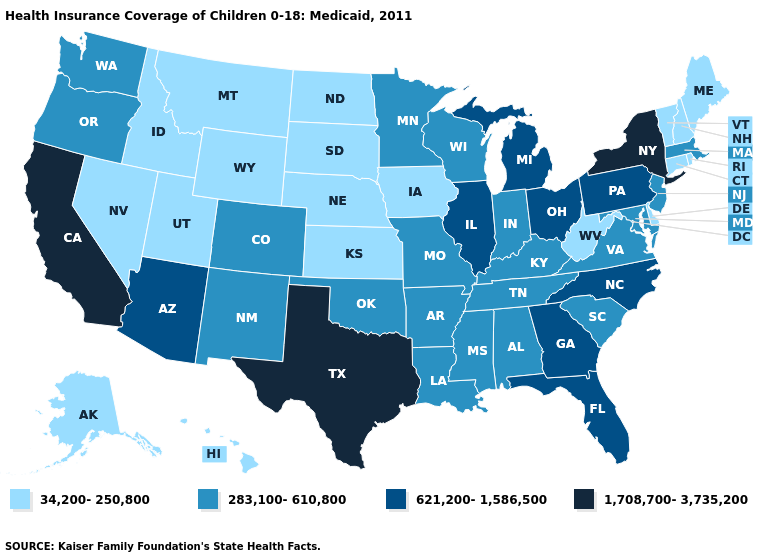Name the states that have a value in the range 621,200-1,586,500?
Quick response, please. Arizona, Florida, Georgia, Illinois, Michigan, North Carolina, Ohio, Pennsylvania. Among the states that border New Hampshire , does Maine have the lowest value?
Write a very short answer. Yes. What is the lowest value in the USA?
Quick response, please. 34,200-250,800. Among the states that border Delaware , which have the highest value?
Short answer required. Pennsylvania. Name the states that have a value in the range 283,100-610,800?
Short answer required. Alabama, Arkansas, Colorado, Indiana, Kentucky, Louisiana, Maryland, Massachusetts, Minnesota, Mississippi, Missouri, New Jersey, New Mexico, Oklahoma, Oregon, South Carolina, Tennessee, Virginia, Washington, Wisconsin. Does Illinois have the highest value in the MidWest?
Short answer required. Yes. Does Delaware have the lowest value in the USA?
Write a very short answer. Yes. Which states have the highest value in the USA?
Answer briefly. California, New York, Texas. Does Pennsylvania have the lowest value in the Northeast?
Keep it brief. No. Does Virginia have a lower value than Georgia?
Write a very short answer. Yes. Does Colorado have the lowest value in the West?
Give a very brief answer. No. What is the highest value in the South ?
Write a very short answer. 1,708,700-3,735,200. Which states have the lowest value in the MidWest?
Concise answer only. Iowa, Kansas, Nebraska, North Dakota, South Dakota. What is the highest value in states that border New Jersey?
Keep it brief. 1,708,700-3,735,200. What is the lowest value in the Northeast?
Answer briefly. 34,200-250,800. 